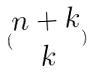Convert formula to latex. <formula><loc_0><loc_0><loc_500><loc_500>( \begin{matrix} n + k \\ k \end{matrix} )</formula> 